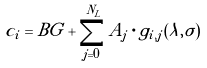Convert formula to latex. <formula><loc_0><loc_0><loc_500><loc_500>c _ { i } = B G + \sum ^ { N _ { L } } _ { j = 0 } A _ { j } \cdot g _ { i , j } ( \lambda , \sigma )</formula> 